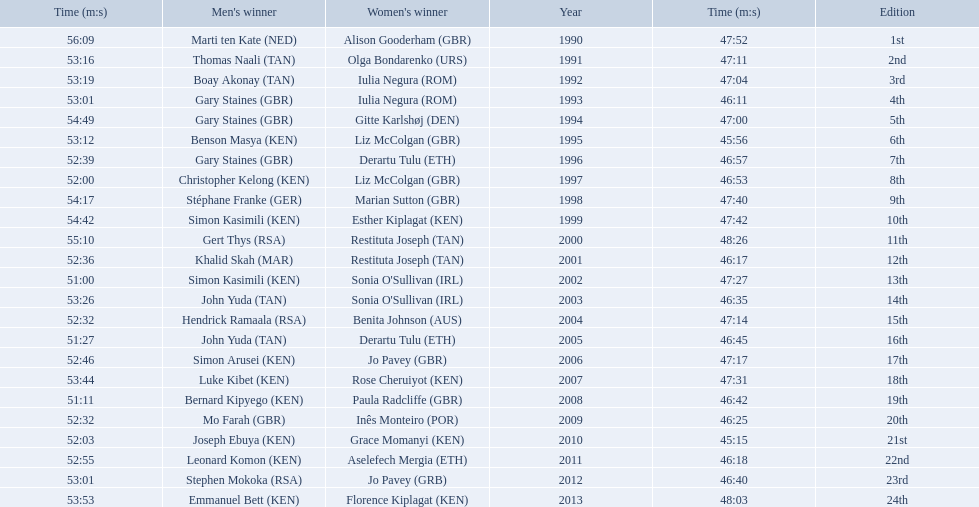What place did sonia o'sullivan finish in 2003? 14th. How long did it take her to finish? 53:26. 